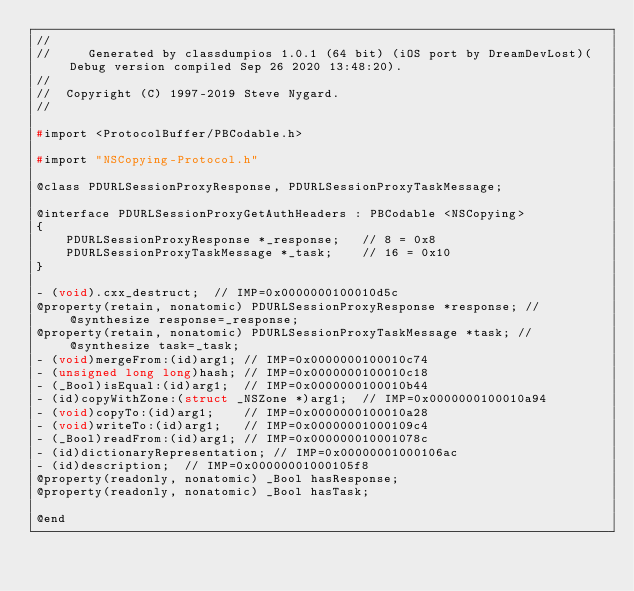<code> <loc_0><loc_0><loc_500><loc_500><_C_>//
//     Generated by classdumpios 1.0.1 (64 bit) (iOS port by DreamDevLost)(Debug version compiled Sep 26 2020 13:48:20).
//
//  Copyright (C) 1997-2019 Steve Nygard.
//

#import <ProtocolBuffer/PBCodable.h>

#import "NSCopying-Protocol.h"

@class PDURLSessionProxyResponse, PDURLSessionProxyTaskMessage;

@interface PDURLSessionProxyGetAuthHeaders : PBCodable <NSCopying>
{
    PDURLSessionProxyResponse *_response;	// 8 = 0x8
    PDURLSessionProxyTaskMessage *_task;	// 16 = 0x10
}

- (void).cxx_destruct;	// IMP=0x0000000100010d5c
@property(retain, nonatomic) PDURLSessionProxyResponse *response; // @synthesize response=_response;
@property(retain, nonatomic) PDURLSessionProxyTaskMessage *task; // @synthesize task=_task;
- (void)mergeFrom:(id)arg1;	// IMP=0x0000000100010c74
- (unsigned long long)hash;	// IMP=0x0000000100010c18
- (_Bool)isEqual:(id)arg1;	// IMP=0x0000000100010b44
- (id)copyWithZone:(struct _NSZone *)arg1;	// IMP=0x0000000100010a94
- (void)copyTo:(id)arg1;	// IMP=0x0000000100010a28
- (void)writeTo:(id)arg1;	// IMP=0x00000001000109c4
- (_Bool)readFrom:(id)arg1;	// IMP=0x000000010001078c
- (id)dictionaryRepresentation;	// IMP=0x00000001000106ac
- (id)description;	// IMP=0x00000001000105f8
@property(readonly, nonatomic) _Bool hasResponse;
@property(readonly, nonatomic) _Bool hasTask;

@end

</code> 